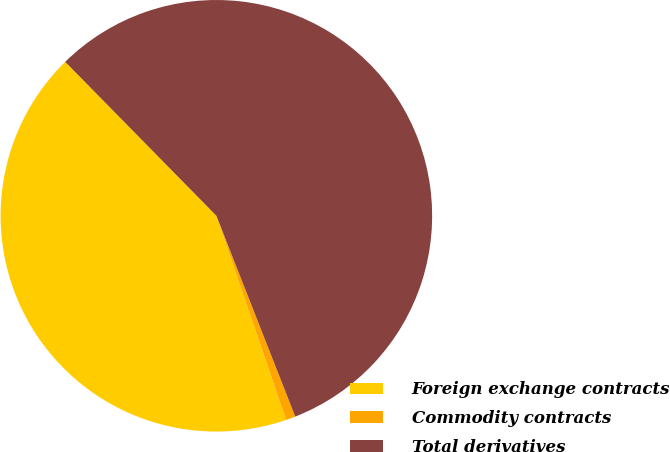<chart> <loc_0><loc_0><loc_500><loc_500><pie_chart><fcel>Foreign exchange contracts<fcel>Commodity contracts<fcel>Total derivatives<nl><fcel>42.88%<fcel>0.72%<fcel>56.4%<nl></chart> 